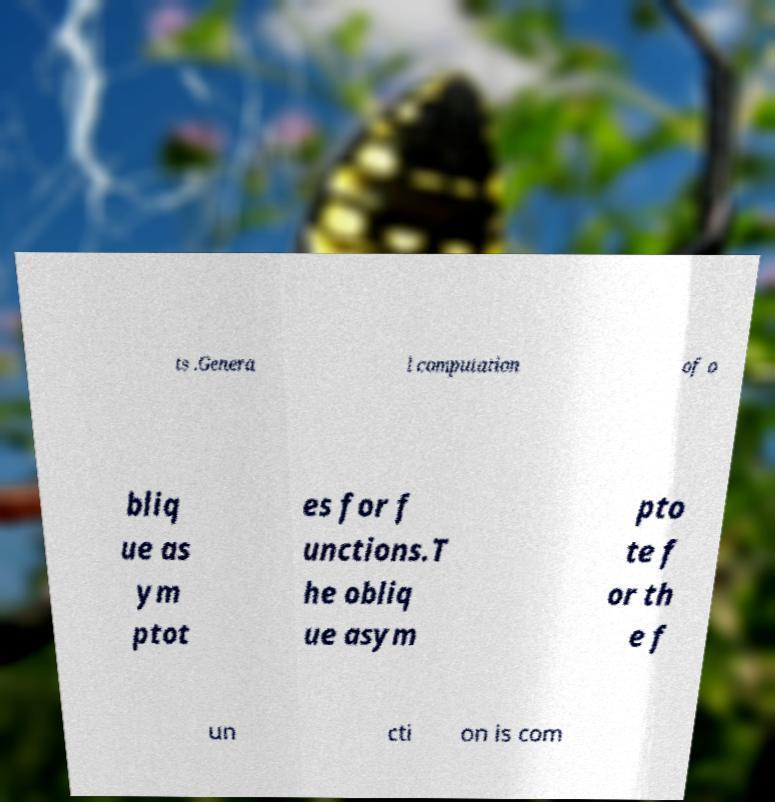What messages or text are displayed in this image? I need them in a readable, typed format. ts .Genera l computation of o bliq ue as ym ptot es for f unctions.T he obliq ue asym pto te f or th e f un cti on is com 